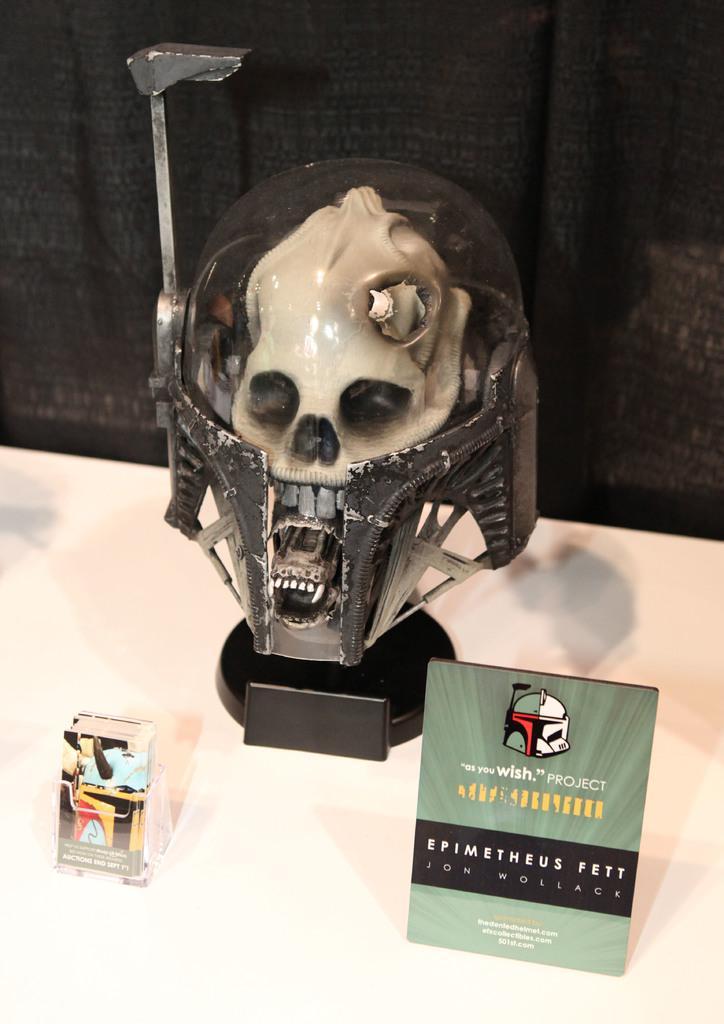In one or two sentences, can you explain what this image depicts? In this image in front there is a depiction of a person and few other objects on the table. Behind the table there are curtains. 